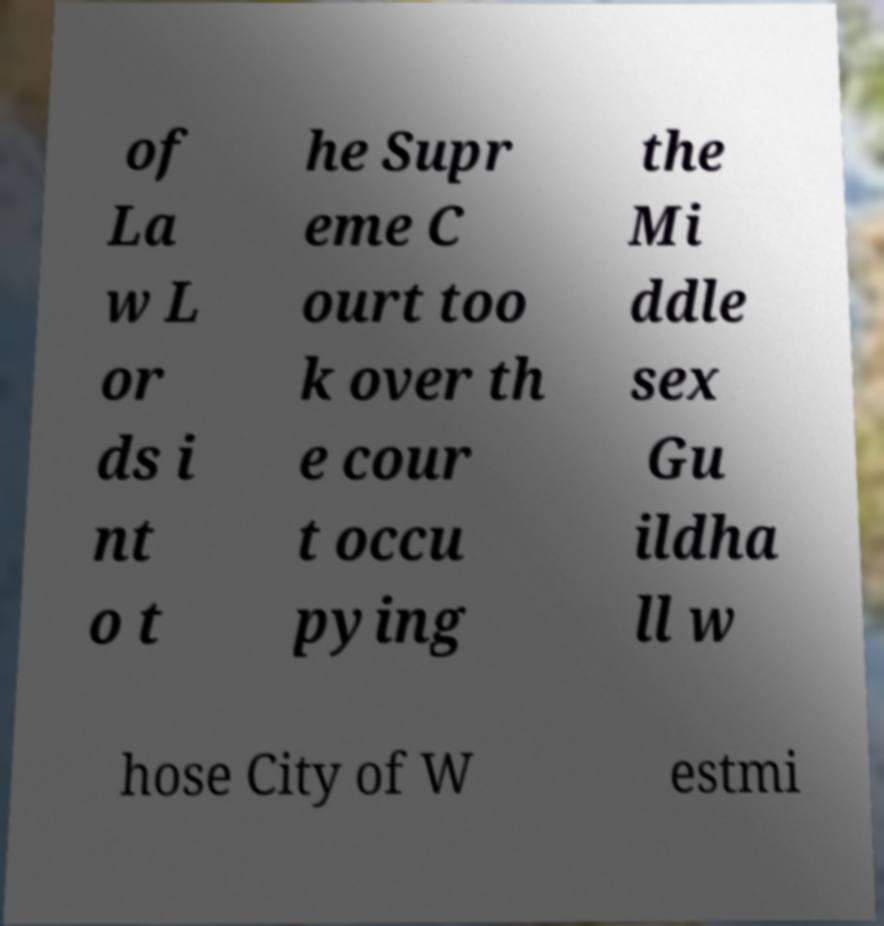Please identify and transcribe the text found in this image. of La w L or ds i nt o t he Supr eme C ourt too k over th e cour t occu pying the Mi ddle sex Gu ildha ll w hose City of W estmi 